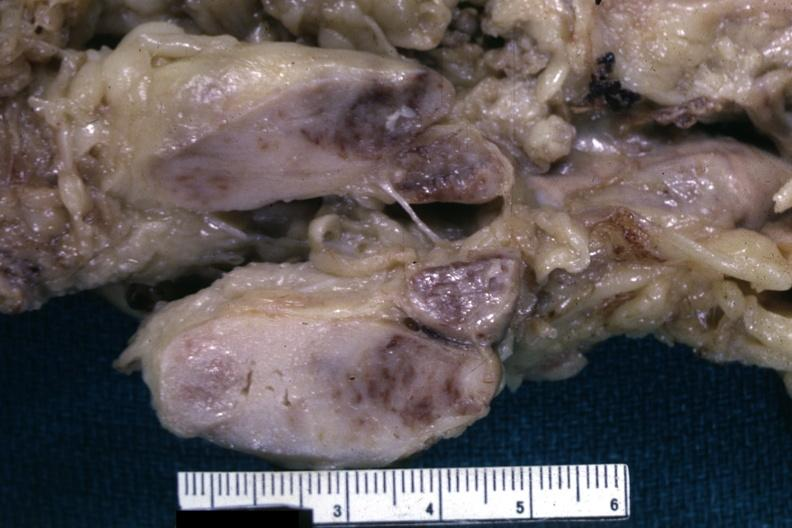what is unknown could have been a seminoma see other slides?
Answer the question using a single word or phrase. Matting history of this case 